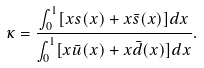Convert formula to latex. <formula><loc_0><loc_0><loc_500><loc_500>\kappa = \frac { \int _ { 0 } ^ { 1 } [ x s ( x ) + x \bar { s } ( x ) ] d x } { \int _ { 0 } ^ { 1 } [ x \bar { u } ( x ) + x \bar { d } ( x ) ] d x } .</formula> 